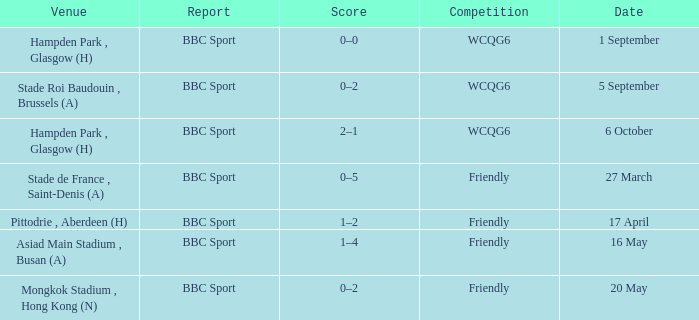Who reported the game played on 1 september? BBC Sport. 